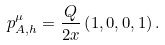<formula> <loc_0><loc_0><loc_500><loc_500>p _ { A , h } ^ { \mu } = \frac { Q } { 2 x } \left ( 1 , 0 , 0 , 1 \right ) .</formula> 